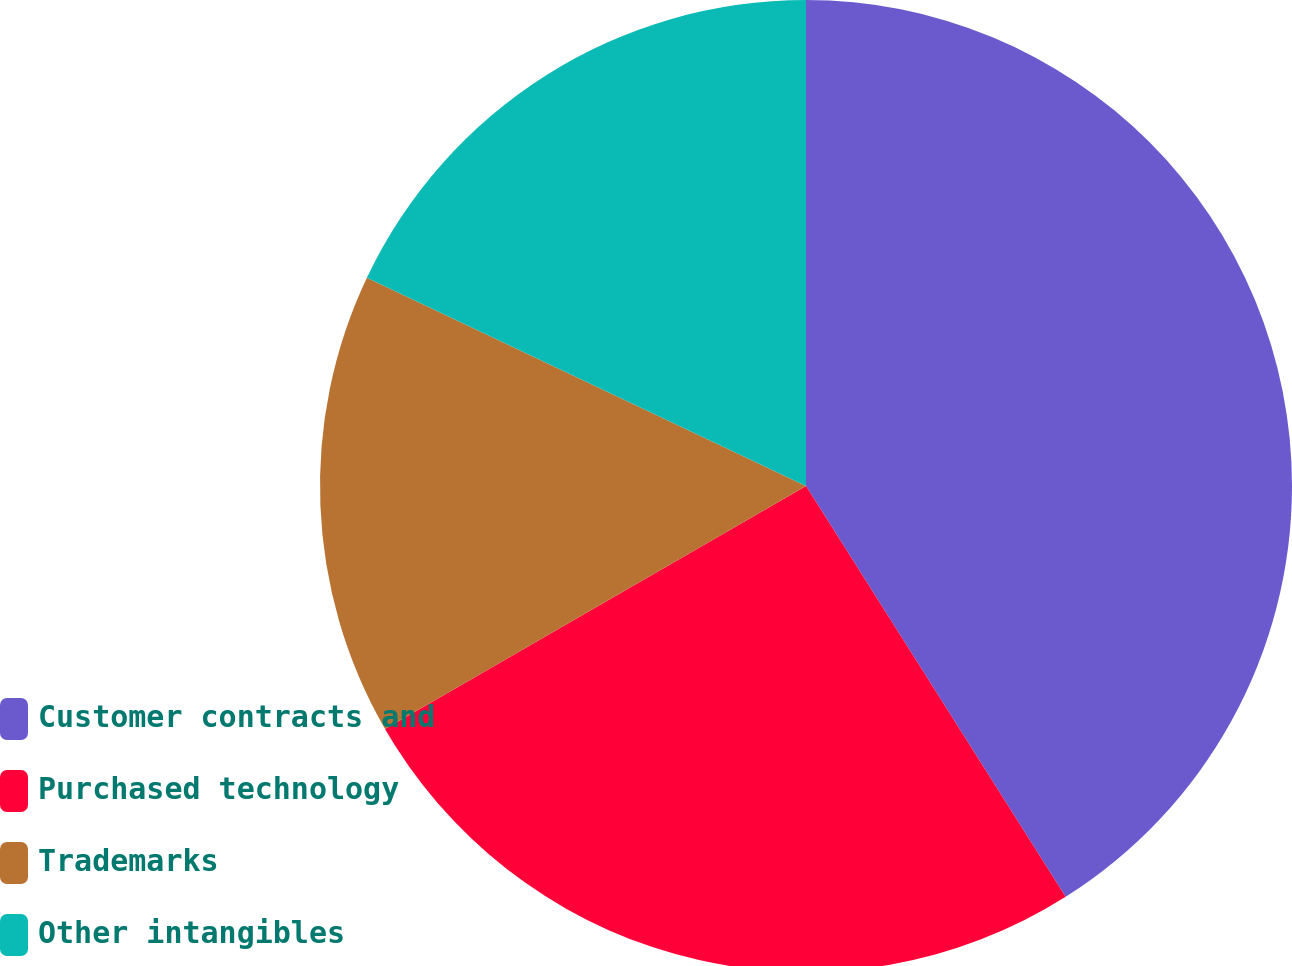<chart> <loc_0><loc_0><loc_500><loc_500><pie_chart><fcel>Customer contracts and<fcel>Purchased technology<fcel>Trademarks<fcel>Other intangibles<nl><fcel>41.03%<fcel>25.64%<fcel>15.38%<fcel>17.95%<nl></chart> 